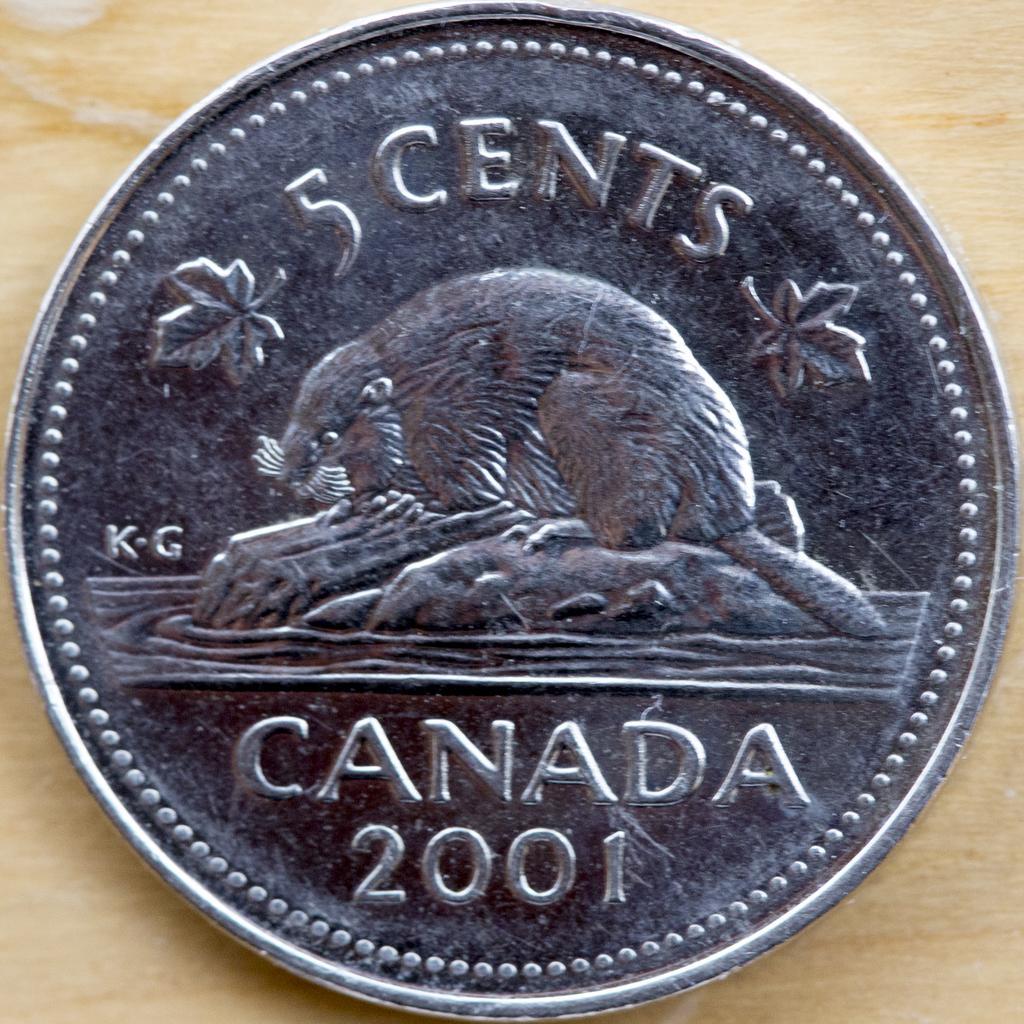In one or two sentences, can you explain what this image depicts? In this image there is a coin of 5 cents on the table. 